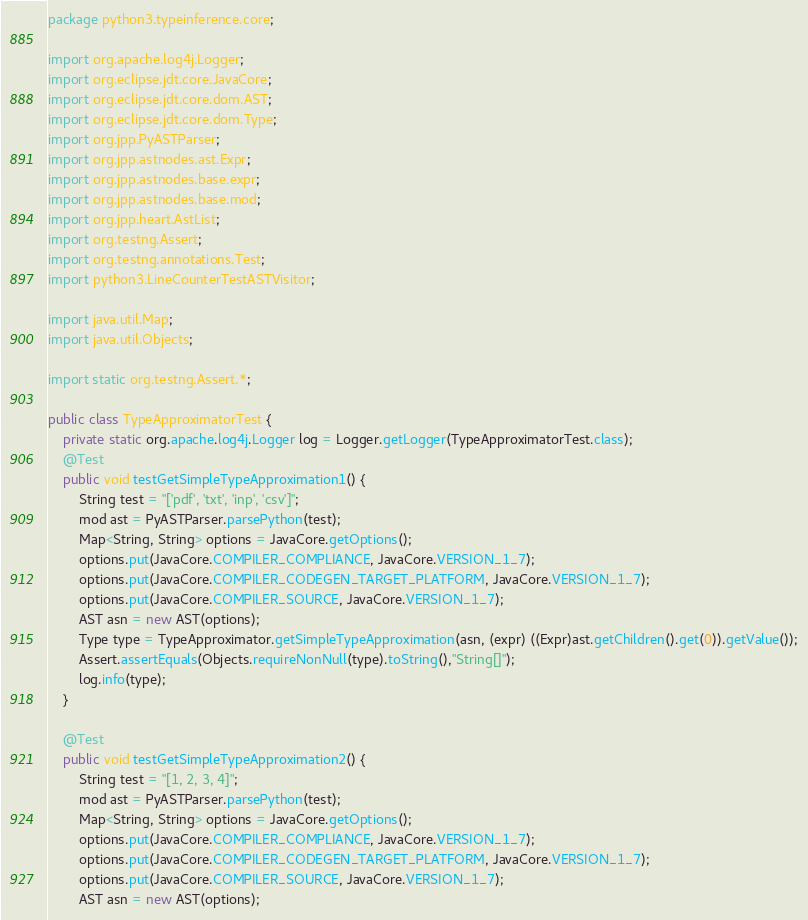Convert code to text. <code><loc_0><loc_0><loc_500><loc_500><_Java_>package python3.typeinference.core;

import org.apache.log4j.Logger;
import org.eclipse.jdt.core.JavaCore;
import org.eclipse.jdt.core.dom.AST;
import org.eclipse.jdt.core.dom.Type;
import org.jpp.PyASTParser;
import org.jpp.astnodes.ast.Expr;
import org.jpp.astnodes.base.expr;
import org.jpp.astnodes.base.mod;
import org.jpp.heart.AstList;
import org.testng.Assert;
import org.testng.annotations.Test;
import python3.LineCounterTestASTVisitor;

import java.util.Map;
import java.util.Objects;

import static org.testng.Assert.*;

public class TypeApproximatorTest {
    private static org.apache.log4j.Logger log = Logger.getLogger(TypeApproximatorTest.class);
    @Test
    public void testGetSimpleTypeApproximation1() {
        String test = "['pdf', 'txt', 'inp', 'csv']";
        mod ast = PyASTParser.parsePython(test);
        Map<String, String> options = JavaCore.getOptions();
        options.put(JavaCore.COMPILER_COMPLIANCE, JavaCore.VERSION_1_7);
        options.put(JavaCore.COMPILER_CODEGEN_TARGET_PLATFORM, JavaCore.VERSION_1_7);
        options.put(JavaCore.COMPILER_SOURCE, JavaCore.VERSION_1_7);
        AST asn = new AST(options);
        Type type = TypeApproximator.getSimpleTypeApproximation(asn, (expr) ((Expr)ast.getChildren().get(0)).getValue());
        Assert.assertEquals(Objects.requireNonNull(type).toString(),"String[]");
        log.info(type);
    }

    @Test
    public void testGetSimpleTypeApproximation2() {
        String test = "[1, 2, 3, 4]";
        mod ast = PyASTParser.parsePython(test);
        Map<String, String> options = JavaCore.getOptions();
        options.put(JavaCore.COMPILER_COMPLIANCE, JavaCore.VERSION_1_7);
        options.put(JavaCore.COMPILER_CODEGEN_TARGET_PLATFORM, JavaCore.VERSION_1_7);
        options.put(JavaCore.COMPILER_SOURCE, JavaCore.VERSION_1_7);
        AST asn = new AST(options);</code> 